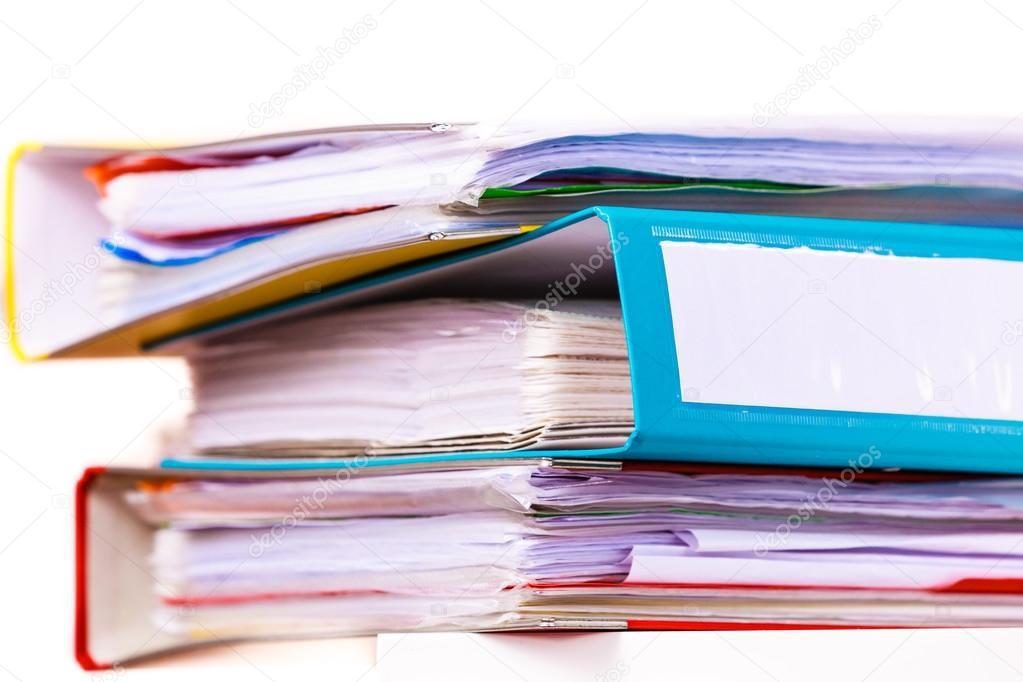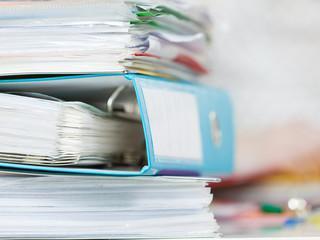The first image is the image on the left, the second image is the image on the right. Evaluate the accuracy of this statement regarding the images: "At least one image shows binders lying on their sides, in a kind of stack.". Is it true? Answer yes or no. Yes. The first image is the image on the left, the second image is the image on the right. For the images shown, is this caption "There is one binder in the the image on the right." true? Answer yes or no. No. 